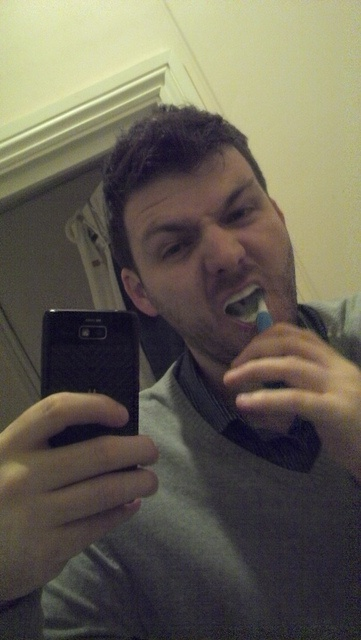Describe the objects in this image and their specific colors. I can see people in khaki, black, and gray tones, cell phone in khaki, black, and gray tones, and toothbrush in khaki, gray, blue, and black tones in this image. 